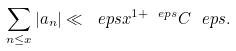Convert formula to latex. <formula><loc_0><loc_0><loc_500><loc_500>\sum _ { n \leq x } | a _ { n } | \ll _ { \ } e p s x ^ { 1 + \ e p s } C ^ { \ } e p s .</formula> 